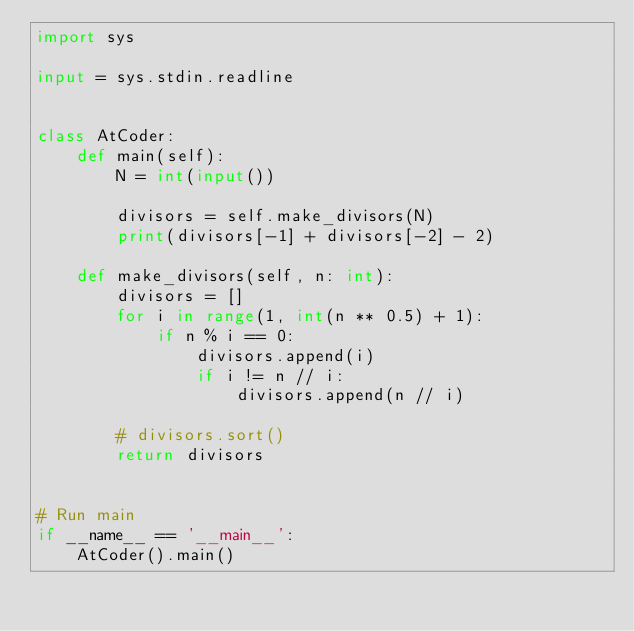Convert code to text. <code><loc_0><loc_0><loc_500><loc_500><_Python_>import sys

input = sys.stdin.readline


class AtCoder:
    def main(self):
        N = int(input())

        divisors = self.make_divisors(N)
        print(divisors[-1] + divisors[-2] - 2)

    def make_divisors(self, n: int):
        divisors = []
        for i in range(1, int(n ** 0.5) + 1):
            if n % i == 0:
                divisors.append(i)
                if i != n // i:
                    divisors.append(n // i)

        # divisors.sort()
        return divisors


# Run main
if __name__ == '__main__':
    AtCoder().main()
</code> 